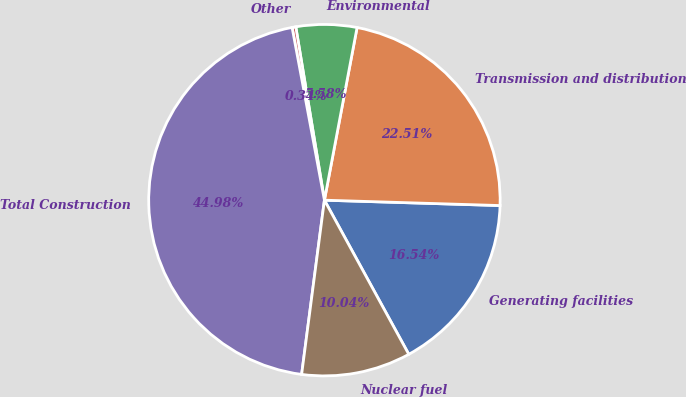Convert chart to OTSL. <chart><loc_0><loc_0><loc_500><loc_500><pie_chart><fcel>Generating facilities<fcel>Transmission and distribution<fcel>Environmental<fcel>Other<fcel>Total Construction<fcel>Nuclear fuel<nl><fcel>16.54%<fcel>22.51%<fcel>5.58%<fcel>0.34%<fcel>44.98%<fcel>10.04%<nl></chart> 